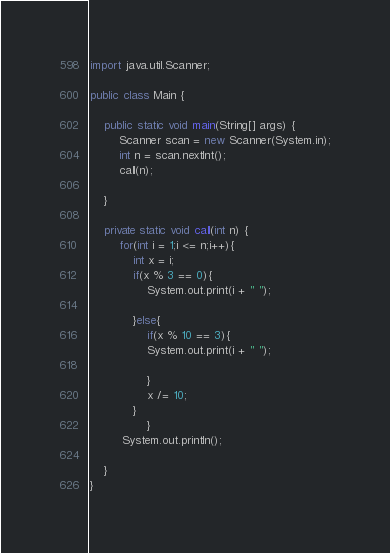Convert code to text. <code><loc_0><loc_0><loc_500><loc_500><_Java_>import java.util.Scanner;

public class Main {

	public static void main(String[] args) {
		Scanner scan = new Scanner(System.in);
		int n = scan.nextInt();
		call(n);

	}

	private static void call(int n) {
		for(int i = 1;i <= n;i++){
			int x = i;
			if(x % 3 == 0){
				System.out.print(i + " ");
 
			}else{
				if(x % 10 == 3){
				System.out.print(i + " ");
                                        
				}
				x /= 10;
			}
                }
         System.out.println();

	}
}</code> 